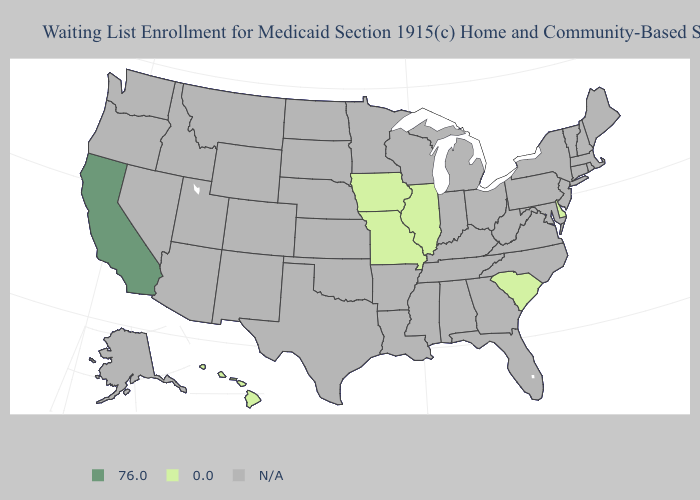Name the states that have a value in the range 76.0?
Keep it brief. California. Name the states that have a value in the range 0.0?
Give a very brief answer. Delaware, Hawaii, Illinois, Iowa, Missouri, South Carolina. What is the value of Vermont?
Keep it brief. N/A. Does California have the highest value in the West?
Give a very brief answer. Yes. Name the states that have a value in the range N/A?
Give a very brief answer. Alabama, Alaska, Arizona, Arkansas, Colorado, Connecticut, Florida, Georgia, Idaho, Indiana, Kansas, Kentucky, Louisiana, Maine, Maryland, Massachusetts, Michigan, Minnesota, Mississippi, Montana, Nebraska, Nevada, New Hampshire, New Jersey, New Mexico, New York, North Carolina, North Dakota, Ohio, Oklahoma, Oregon, Pennsylvania, Rhode Island, South Dakota, Tennessee, Texas, Utah, Vermont, Virginia, Washington, West Virginia, Wisconsin, Wyoming. Which states hav the highest value in the West?
Be succinct. California. Name the states that have a value in the range 76.0?
Give a very brief answer. California. Which states have the lowest value in the USA?
Be succinct. Delaware, Hawaii, Illinois, Iowa, Missouri, South Carolina. Does Missouri have the highest value in the USA?
Write a very short answer. No. Which states have the lowest value in the MidWest?
Keep it brief. Illinois, Iowa, Missouri. What is the highest value in the South ?
Answer briefly. 0.0. 